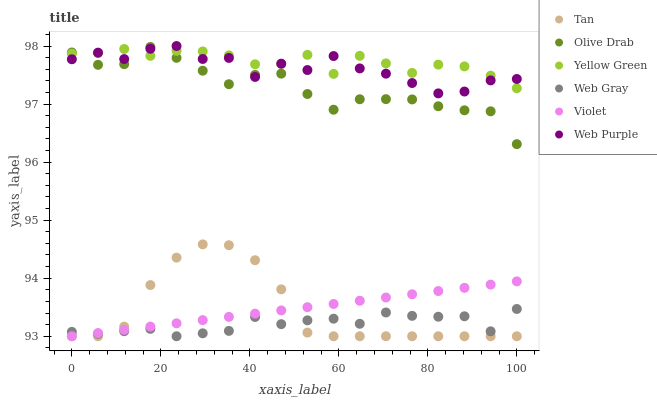Does Web Gray have the minimum area under the curve?
Answer yes or no. Yes. Does Yellow Green have the maximum area under the curve?
Answer yes or no. Yes. Does Web Purple have the minimum area under the curve?
Answer yes or no. No. Does Web Purple have the maximum area under the curve?
Answer yes or no. No. Is Violet the smoothest?
Answer yes or no. Yes. Is Web Purple the roughest?
Answer yes or no. Yes. Is Yellow Green the smoothest?
Answer yes or no. No. Is Yellow Green the roughest?
Answer yes or no. No. Does Web Gray have the lowest value?
Answer yes or no. Yes. Does Web Purple have the lowest value?
Answer yes or no. No. Does Web Purple have the highest value?
Answer yes or no. Yes. Does Yellow Green have the highest value?
Answer yes or no. No. Is Violet less than Yellow Green?
Answer yes or no. Yes. Is Yellow Green greater than Tan?
Answer yes or no. Yes. Does Tan intersect Web Gray?
Answer yes or no. Yes. Is Tan less than Web Gray?
Answer yes or no. No. Is Tan greater than Web Gray?
Answer yes or no. No. Does Violet intersect Yellow Green?
Answer yes or no. No. 